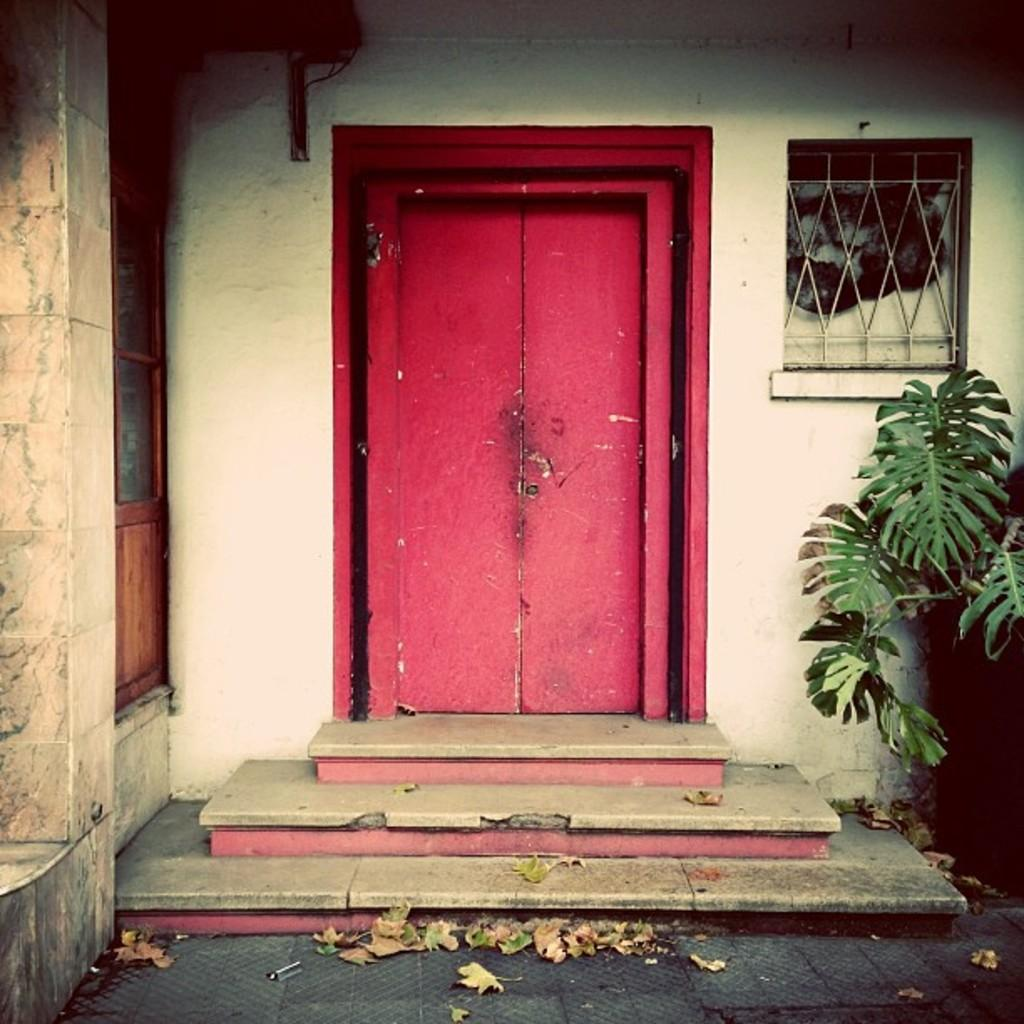What is the color of the wall in the image? The wall in the image is white. What can be found on the wall in the image? There is a door in the image. What other feature is present on the wall in the image? There is a window in the image. What type of object is visible in the image that is not part of the wall? There is a plant in the image. What type of frame is visible around the plant in the image? There is no frame visible around the plant in the image. 